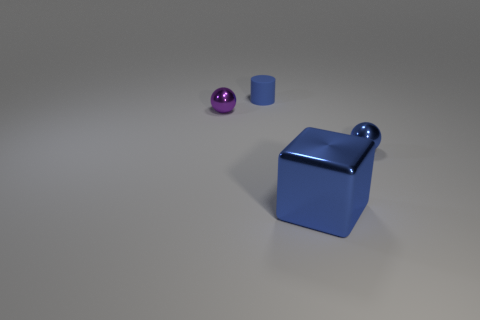Add 2 shiny things. How many objects exist? 6 Subtract all cylinders. How many objects are left? 3 Subtract all cyan balls. Subtract all brown cubes. How many balls are left? 2 Subtract all yellow cylinders. How many blue balls are left? 1 Subtract all big matte balls. Subtract all big shiny things. How many objects are left? 3 Add 1 rubber cylinders. How many rubber cylinders are left? 2 Add 4 small blue matte balls. How many small blue matte balls exist? 4 Subtract 0 yellow cylinders. How many objects are left? 4 Subtract 1 balls. How many balls are left? 1 